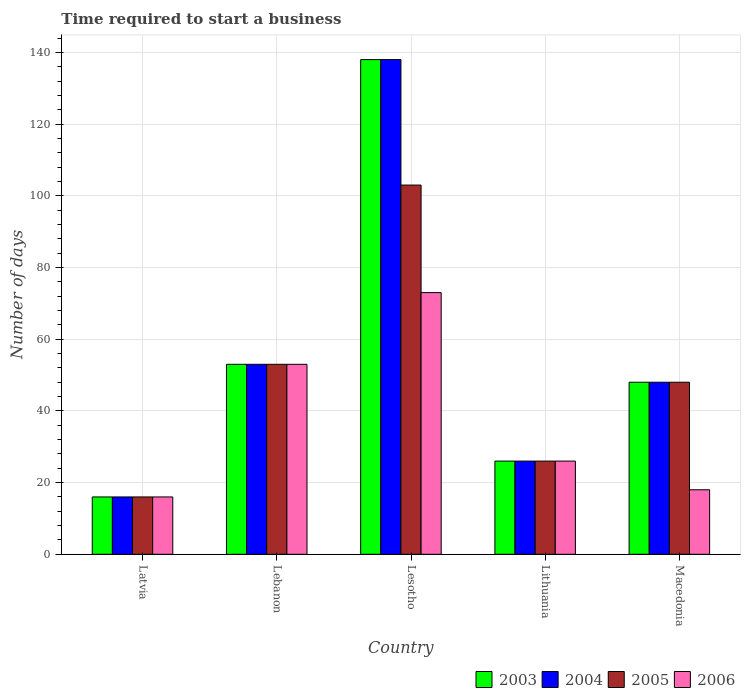How many bars are there on the 3rd tick from the right?
Keep it short and to the point. 4. What is the label of the 2nd group of bars from the left?
Keep it short and to the point. Lebanon. In how many cases, is the number of bars for a given country not equal to the number of legend labels?
Your response must be concise. 0. In which country was the number of days required to start a business in 2003 maximum?
Keep it short and to the point. Lesotho. In which country was the number of days required to start a business in 2003 minimum?
Give a very brief answer. Latvia. What is the total number of days required to start a business in 2003 in the graph?
Offer a very short reply. 281. What is the difference between the number of days required to start a business in 2004 in Latvia and the number of days required to start a business in 2006 in Lithuania?
Ensure brevity in your answer.  -10. What is the average number of days required to start a business in 2003 per country?
Your response must be concise. 56.2. What is the difference between the number of days required to start a business of/in 2003 and number of days required to start a business of/in 2004 in Lesotho?
Your answer should be very brief. 0. In how many countries, is the number of days required to start a business in 2006 greater than 32 days?
Your response must be concise. 2. What is the ratio of the number of days required to start a business in 2004 in Lebanon to that in Macedonia?
Keep it short and to the point. 1.1. What is the difference between the highest and the second highest number of days required to start a business in 2005?
Your answer should be very brief. -5. What is the difference between the highest and the lowest number of days required to start a business in 2004?
Keep it short and to the point. 122. In how many countries, is the number of days required to start a business in 2004 greater than the average number of days required to start a business in 2004 taken over all countries?
Offer a very short reply. 1. Is the sum of the number of days required to start a business in 2005 in Lebanon and Lithuania greater than the maximum number of days required to start a business in 2006 across all countries?
Provide a succinct answer. Yes. Is it the case that in every country, the sum of the number of days required to start a business in 2005 and number of days required to start a business in 2004 is greater than the sum of number of days required to start a business in 2003 and number of days required to start a business in 2006?
Your answer should be compact. No. What does the 3rd bar from the left in Lithuania represents?
Keep it short and to the point. 2005. What does the 1st bar from the right in Lithuania represents?
Give a very brief answer. 2006. Are all the bars in the graph horizontal?
Offer a very short reply. No. Does the graph contain grids?
Your answer should be compact. Yes. How many legend labels are there?
Provide a succinct answer. 4. How are the legend labels stacked?
Your response must be concise. Horizontal. What is the title of the graph?
Make the answer very short. Time required to start a business. What is the label or title of the Y-axis?
Keep it short and to the point. Number of days. What is the Number of days in 2004 in Latvia?
Your answer should be compact. 16. What is the Number of days of 2005 in Latvia?
Give a very brief answer. 16. What is the Number of days of 2006 in Latvia?
Offer a terse response. 16. What is the Number of days of 2004 in Lebanon?
Offer a very short reply. 53. What is the Number of days of 2005 in Lebanon?
Give a very brief answer. 53. What is the Number of days in 2003 in Lesotho?
Provide a succinct answer. 138. What is the Number of days in 2004 in Lesotho?
Ensure brevity in your answer.  138. What is the Number of days of 2005 in Lesotho?
Your answer should be compact. 103. What is the Number of days in 2003 in Lithuania?
Offer a terse response. 26. What is the Number of days of 2006 in Lithuania?
Offer a very short reply. 26. What is the Number of days of 2005 in Macedonia?
Your answer should be very brief. 48. What is the Number of days of 2006 in Macedonia?
Keep it short and to the point. 18. Across all countries, what is the maximum Number of days of 2003?
Provide a short and direct response. 138. Across all countries, what is the maximum Number of days in 2004?
Provide a short and direct response. 138. Across all countries, what is the maximum Number of days in 2005?
Ensure brevity in your answer.  103. Across all countries, what is the minimum Number of days in 2003?
Your answer should be compact. 16. Across all countries, what is the minimum Number of days in 2005?
Offer a terse response. 16. What is the total Number of days of 2003 in the graph?
Make the answer very short. 281. What is the total Number of days in 2004 in the graph?
Offer a very short reply. 281. What is the total Number of days of 2005 in the graph?
Give a very brief answer. 246. What is the total Number of days in 2006 in the graph?
Your response must be concise. 186. What is the difference between the Number of days of 2003 in Latvia and that in Lebanon?
Keep it short and to the point. -37. What is the difference between the Number of days of 2004 in Latvia and that in Lebanon?
Make the answer very short. -37. What is the difference between the Number of days in 2005 in Latvia and that in Lebanon?
Make the answer very short. -37. What is the difference between the Number of days of 2006 in Latvia and that in Lebanon?
Offer a very short reply. -37. What is the difference between the Number of days of 2003 in Latvia and that in Lesotho?
Give a very brief answer. -122. What is the difference between the Number of days of 2004 in Latvia and that in Lesotho?
Keep it short and to the point. -122. What is the difference between the Number of days in 2005 in Latvia and that in Lesotho?
Provide a short and direct response. -87. What is the difference between the Number of days of 2006 in Latvia and that in Lesotho?
Your answer should be compact. -57. What is the difference between the Number of days in 2004 in Latvia and that in Lithuania?
Your response must be concise. -10. What is the difference between the Number of days in 2005 in Latvia and that in Lithuania?
Offer a terse response. -10. What is the difference between the Number of days of 2006 in Latvia and that in Lithuania?
Provide a succinct answer. -10. What is the difference between the Number of days in 2003 in Latvia and that in Macedonia?
Make the answer very short. -32. What is the difference between the Number of days of 2004 in Latvia and that in Macedonia?
Ensure brevity in your answer.  -32. What is the difference between the Number of days in 2005 in Latvia and that in Macedonia?
Provide a succinct answer. -32. What is the difference between the Number of days in 2003 in Lebanon and that in Lesotho?
Your response must be concise. -85. What is the difference between the Number of days in 2004 in Lebanon and that in Lesotho?
Provide a succinct answer. -85. What is the difference between the Number of days in 2006 in Lebanon and that in Lesotho?
Ensure brevity in your answer.  -20. What is the difference between the Number of days of 2003 in Lebanon and that in Lithuania?
Provide a succinct answer. 27. What is the difference between the Number of days in 2004 in Lebanon and that in Lithuania?
Ensure brevity in your answer.  27. What is the difference between the Number of days in 2005 in Lebanon and that in Lithuania?
Give a very brief answer. 27. What is the difference between the Number of days of 2006 in Lebanon and that in Lithuania?
Your answer should be compact. 27. What is the difference between the Number of days of 2003 in Lebanon and that in Macedonia?
Your response must be concise. 5. What is the difference between the Number of days in 2003 in Lesotho and that in Lithuania?
Give a very brief answer. 112. What is the difference between the Number of days of 2004 in Lesotho and that in Lithuania?
Offer a terse response. 112. What is the difference between the Number of days in 2006 in Lesotho and that in Lithuania?
Provide a succinct answer. 47. What is the difference between the Number of days of 2003 in Lesotho and that in Macedonia?
Ensure brevity in your answer.  90. What is the difference between the Number of days of 2004 in Lesotho and that in Macedonia?
Offer a terse response. 90. What is the difference between the Number of days in 2006 in Lesotho and that in Macedonia?
Keep it short and to the point. 55. What is the difference between the Number of days in 2004 in Lithuania and that in Macedonia?
Provide a succinct answer. -22. What is the difference between the Number of days in 2005 in Lithuania and that in Macedonia?
Provide a short and direct response. -22. What is the difference between the Number of days of 2006 in Lithuania and that in Macedonia?
Your answer should be compact. 8. What is the difference between the Number of days in 2003 in Latvia and the Number of days in 2004 in Lebanon?
Provide a succinct answer. -37. What is the difference between the Number of days in 2003 in Latvia and the Number of days in 2005 in Lebanon?
Your response must be concise. -37. What is the difference between the Number of days of 2003 in Latvia and the Number of days of 2006 in Lebanon?
Your response must be concise. -37. What is the difference between the Number of days in 2004 in Latvia and the Number of days in 2005 in Lebanon?
Your answer should be compact. -37. What is the difference between the Number of days in 2004 in Latvia and the Number of days in 2006 in Lebanon?
Keep it short and to the point. -37. What is the difference between the Number of days of 2005 in Latvia and the Number of days of 2006 in Lebanon?
Your answer should be very brief. -37. What is the difference between the Number of days in 2003 in Latvia and the Number of days in 2004 in Lesotho?
Your response must be concise. -122. What is the difference between the Number of days of 2003 in Latvia and the Number of days of 2005 in Lesotho?
Your answer should be very brief. -87. What is the difference between the Number of days in 2003 in Latvia and the Number of days in 2006 in Lesotho?
Your answer should be very brief. -57. What is the difference between the Number of days of 2004 in Latvia and the Number of days of 2005 in Lesotho?
Your response must be concise. -87. What is the difference between the Number of days of 2004 in Latvia and the Number of days of 2006 in Lesotho?
Make the answer very short. -57. What is the difference between the Number of days in 2005 in Latvia and the Number of days in 2006 in Lesotho?
Your answer should be compact. -57. What is the difference between the Number of days of 2003 in Latvia and the Number of days of 2004 in Lithuania?
Provide a succinct answer. -10. What is the difference between the Number of days in 2003 in Latvia and the Number of days in 2005 in Lithuania?
Provide a short and direct response. -10. What is the difference between the Number of days of 2004 in Latvia and the Number of days of 2005 in Lithuania?
Offer a very short reply. -10. What is the difference between the Number of days in 2005 in Latvia and the Number of days in 2006 in Lithuania?
Your answer should be very brief. -10. What is the difference between the Number of days in 2003 in Latvia and the Number of days in 2004 in Macedonia?
Give a very brief answer. -32. What is the difference between the Number of days of 2003 in Latvia and the Number of days of 2005 in Macedonia?
Your answer should be very brief. -32. What is the difference between the Number of days of 2004 in Latvia and the Number of days of 2005 in Macedonia?
Your answer should be compact. -32. What is the difference between the Number of days in 2005 in Latvia and the Number of days in 2006 in Macedonia?
Give a very brief answer. -2. What is the difference between the Number of days of 2003 in Lebanon and the Number of days of 2004 in Lesotho?
Ensure brevity in your answer.  -85. What is the difference between the Number of days in 2003 in Lebanon and the Number of days in 2004 in Lithuania?
Ensure brevity in your answer.  27. What is the difference between the Number of days in 2003 in Lebanon and the Number of days in 2005 in Lithuania?
Ensure brevity in your answer.  27. What is the difference between the Number of days in 2004 in Lebanon and the Number of days in 2005 in Lithuania?
Provide a succinct answer. 27. What is the difference between the Number of days in 2004 in Lebanon and the Number of days in 2006 in Lithuania?
Give a very brief answer. 27. What is the difference between the Number of days of 2005 in Lebanon and the Number of days of 2006 in Lithuania?
Keep it short and to the point. 27. What is the difference between the Number of days of 2003 in Lebanon and the Number of days of 2004 in Macedonia?
Offer a very short reply. 5. What is the difference between the Number of days of 2003 in Lebanon and the Number of days of 2006 in Macedonia?
Provide a succinct answer. 35. What is the difference between the Number of days of 2004 in Lebanon and the Number of days of 2005 in Macedonia?
Your response must be concise. 5. What is the difference between the Number of days of 2004 in Lebanon and the Number of days of 2006 in Macedonia?
Ensure brevity in your answer.  35. What is the difference between the Number of days in 2003 in Lesotho and the Number of days in 2004 in Lithuania?
Your answer should be very brief. 112. What is the difference between the Number of days in 2003 in Lesotho and the Number of days in 2005 in Lithuania?
Offer a very short reply. 112. What is the difference between the Number of days of 2003 in Lesotho and the Number of days of 2006 in Lithuania?
Ensure brevity in your answer.  112. What is the difference between the Number of days in 2004 in Lesotho and the Number of days in 2005 in Lithuania?
Your answer should be compact. 112. What is the difference between the Number of days in 2004 in Lesotho and the Number of days in 2006 in Lithuania?
Keep it short and to the point. 112. What is the difference between the Number of days of 2003 in Lesotho and the Number of days of 2004 in Macedonia?
Keep it short and to the point. 90. What is the difference between the Number of days in 2003 in Lesotho and the Number of days in 2006 in Macedonia?
Offer a terse response. 120. What is the difference between the Number of days in 2004 in Lesotho and the Number of days in 2005 in Macedonia?
Your answer should be very brief. 90. What is the difference between the Number of days in 2004 in Lesotho and the Number of days in 2006 in Macedonia?
Offer a terse response. 120. What is the difference between the Number of days in 2005 in Lesotho and the Number of days in 2006 in Macedonia?
Offer a very short reply. 85. What is the difference between the Number of days of 2003 in Lithuania and the Number of days of 2004 in Macedonia?
Give a very brief answer. -22. What is the difference between the Number of days in 2003 in Lithuania and the Number of days in 2005 in Macedonia?
Ensure brevity in your answer.  -22. What is the difference between the Number of days of 2004 in Lithuania and the Number of days of 2006 in Macedonia?
Provide a succinct answer. 8. What is the average Number of days of 2003 per country?
Ensure brevity in your answer.  56.2. What is the average Number of days of 2004 per country?
Your response must be concise. 56.2. What is the average Number of days in 2005 per country?
Ensure brevity in your answer.  49.2. What is the average Number of days in 2006 per country?
Offer a very short reply. 37.2. What is the difference between the Number of days in 2003 and Number of days in 2004 in Latvia?
Provide a short and direct response. 0. What is the difference between the Number of days of 2003 and Number of days of 2005 in Latvia?
Keep it short and to the point. 0. What is the difference between the Number of days in 2003 and Number of days in 2006 in Latvia?
Offer a terse response. 0. What is the difference between the Number of days of 2004 and Number of days of 2006 in Latvia?
Offer a very short reply. 0. What is the difference between the Number of days in 2005 and Number of days in 2006 in Latvia?
Ensure brevity in your answer.  0. What is the difference between the Number of days in 2004 and Number of days in 2005 in Lebanon?
Give a very brief answer. 0. What is the difference between the Number of days in 2004 and Number of days in 2006 in Lebanon?
Give a very brief answer. 0. What is the difference between the Number of days of 2003 and Number of days of 2004 in Lesotho?
Your response must be concise. 0. What is the difference between the Number of days in 2003 and Number of days in 2006 in Lesotho?
Provide a short and direct response. 65. What is the difference between the Number of days in 2004 and Number of days in 2006 in Lesotho?
Make the answer very short. 65. What is the difference between the Number of days in 2005 and Number of days in 2006 in Lesotho?
Keep it short and to the point. 30. What is the difference between the Number of days of 2003 and Number of days of 2006 in Lithuania?
Your answer should be very brief. 0. What is the difference between the Number of days of 2004 and Number of days of 2006 in Lithuania?
Ensure brevity in your answer.  0. What is the difference between the Number of days of 2003 and Number of days of 2004 in Macedonia?
Offer a very short reply. 0. What is the difference between the Number of days in 2005 and Number of days in 2006 in Macedonia?
Your response must be concise. 30. What is the ratio of the Number of days of 2003 in Latvia to that in Lebanon?
Provide a succinct answer. 0.3. What is the ratio of the Number of days in 2004 in Latvia to that in Lebanon?
Your answer should be compact. 0.3. What is the ratio of the Number of days in 2005 in Latvia to that in Lebanon?
Ensure brevity in your answer.  0.3. What is the ratio of the Number of days in 2006 in Latvia to that in Lebanon?
Ensure brevity in your answer.  0.3. What is the ratio of the Number of days of 2003 in Latvia to that in Lesotho?
Your answer should be very brief. 0.12. What is the ratio of the Number of days of 2004 in Latvia to that in Lesotho?
Give a very brief answer. 0.12. What is the ratio of the Number of days of 2005 in Latvia to that in Lesotho?
Provide a short and direct response. 0.16. What is the ratio of the Number of days of 2006 in Latvia to that in Lesotho?
Make the answer very short. 0.22. What is the ratio of the Number of days of 2003 in Latvia to that in Lithuania?
Offer a very short reply. 0.62. What is the ratio of the Number of days in 2004 in Latvia to that in Lithuania?
Offer a very short reply. 0.62. What is the ratio of the Number of days in 2005 in Latvia to that in Lithuania?
Offer a very short reply. 0.62. What is the ratio of the Number of days in 2006 in Latvia to that in Lithuania?
Keep it short and to the point. 0.62. What is the ratio of the Number of days in 2005 in Latvia to that in Macedonia?
Provide a short and direct response. 0.33. What is the ratio of the Number of days of 2006 in Latvia to that in Macedonia?
Offer a terse response. 0.89. What is the ratio of the Number of days in 2003 in Lebanon to that in Lesotho?
Provide a succinct answer. 0.38. What is the ratio of the Number of days of 2004 in Lebanon to that in Lesotho?
Offer a terse response. 0.38. What is the ratio of the Number of days of 2005 in Lebanon to that in Lesotho?
Keep it short and to the point. 0.51. What is the ratio of the Number of days of 2006 in Lebanon to that in Lesotho?
Make the answer very short. 0.73. What is the ratio of the Number of days in 2003 in Lebanon to that in Lithuania?
Your answer should be compact. 2.04. What is the ratio of the Number of days of 2004 in Lebanon to that in Lithuania?
Your answer should be very brief. 2.04. What is the ratio of the Number of days of 2005 in Lebanon to that in Lithuania?
Your answer should be compact. 2.04. What is the ratio of the Number of days in 2006 in Lebanon to that in Lithuania?
Provide a succinct answer. 2.04. What is the ratio of the Number of days of 2003 in Lebanon to that in Macedonia?
Keep it short and to the point. 1.1. What is the ratio of the Number of days in 2004 in Lebanon to that in Macedonia?
Your answer should be very brief. 1.1. What is the ratio of the Number of days in 2005 in Lebanon to that in Macedonia?
Your answer should be very brief. 1.1. What is the ratio of the Number of days of 2006 in Lebanon to that in Macedonia?
Ensure brevity in your answer.  2.94. What is the ratio of the Number of days in 2003 in Lesotho to that in Lithuania?
Provide a succinct answer. 5.31. What is the ratio of the Number of days of 2004 in Lesotho to that in Lithuania?
Offer a terse response. 5.31. What is the ratio of the Number of days of 2005 in Lesotho to that in Lithuania?
Ensure brevity in your answer.  3.96. What is the ratio of the Number of days in 2006 in Lesotho to that in Lithuania?
Ensure brevity in your answer.  2.81. What is the ratio of the Number of days in 2003 in Lesotho to that in Macedonia?
Offer a very short reply. 2.88. What is the ratio of the Number of days of 2004 in Lesotho to that in Macedonia?
Your answer should be compact. 2.88. What is the ratio of the Number of days in 2005 in Lesotho to that in Macedonia?
Keep it short and to the point. 2.15. What is the ratio of the Number of days in 2006 in Lesotho to that in Macedonia?
Provide a short and direct response. 4.06. What is the ratio of the Number of days of 2003 in Lithuania to that in Macedonia?
Your answer should be compact. 0.54. What is the ratio of the Number of days in 2004 in Lithuania to that in Macedonia?
Offer a very short reply. 0.54. What is the ratio of the Number of days in 2005 in Lithuania to that in Macedonia?
Give a very brief answer. 0.54. What is the ratio of the Number of days of 2006 in Lithuania to that in Macedonia?
Your response must be concise. 1.44. What is the difference between the highest and the second highest Number of days in 2004?
Offer a very short reply. 85. What is the difference between the highest and the second highest Number of days in 2005?
Ensure brevity in your answer.  50. What is the difference between the highest and the second highest Number of days in 2006?
Provide a succinct answer. 20. What is the difference between the highest and the lowest Number of days in 2003?
Provide a succinct answer. 122. What is the difference between the highest and the lowest Number of days in 2004?
Your answer should be compact. 122. 